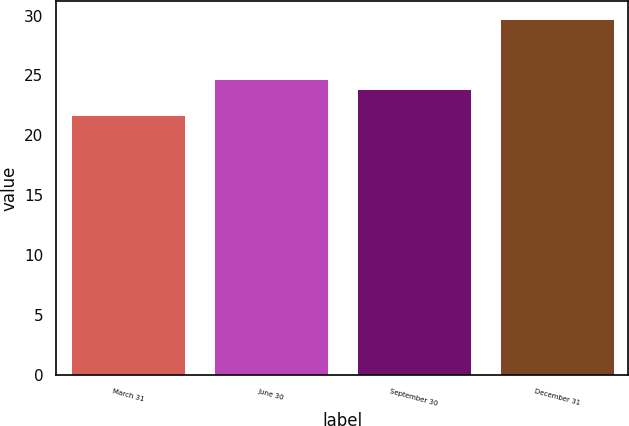Convert chart. <chart><loc_0><loc_0><loc_500><loc_500><bar_chart><fcel>March 31<fcel>June 30<fcel>September 30<fcel>December 31<nl><fcel>21.7<fcel>24.7<fcel>23.9<fcel>29.7<nl></chart> 